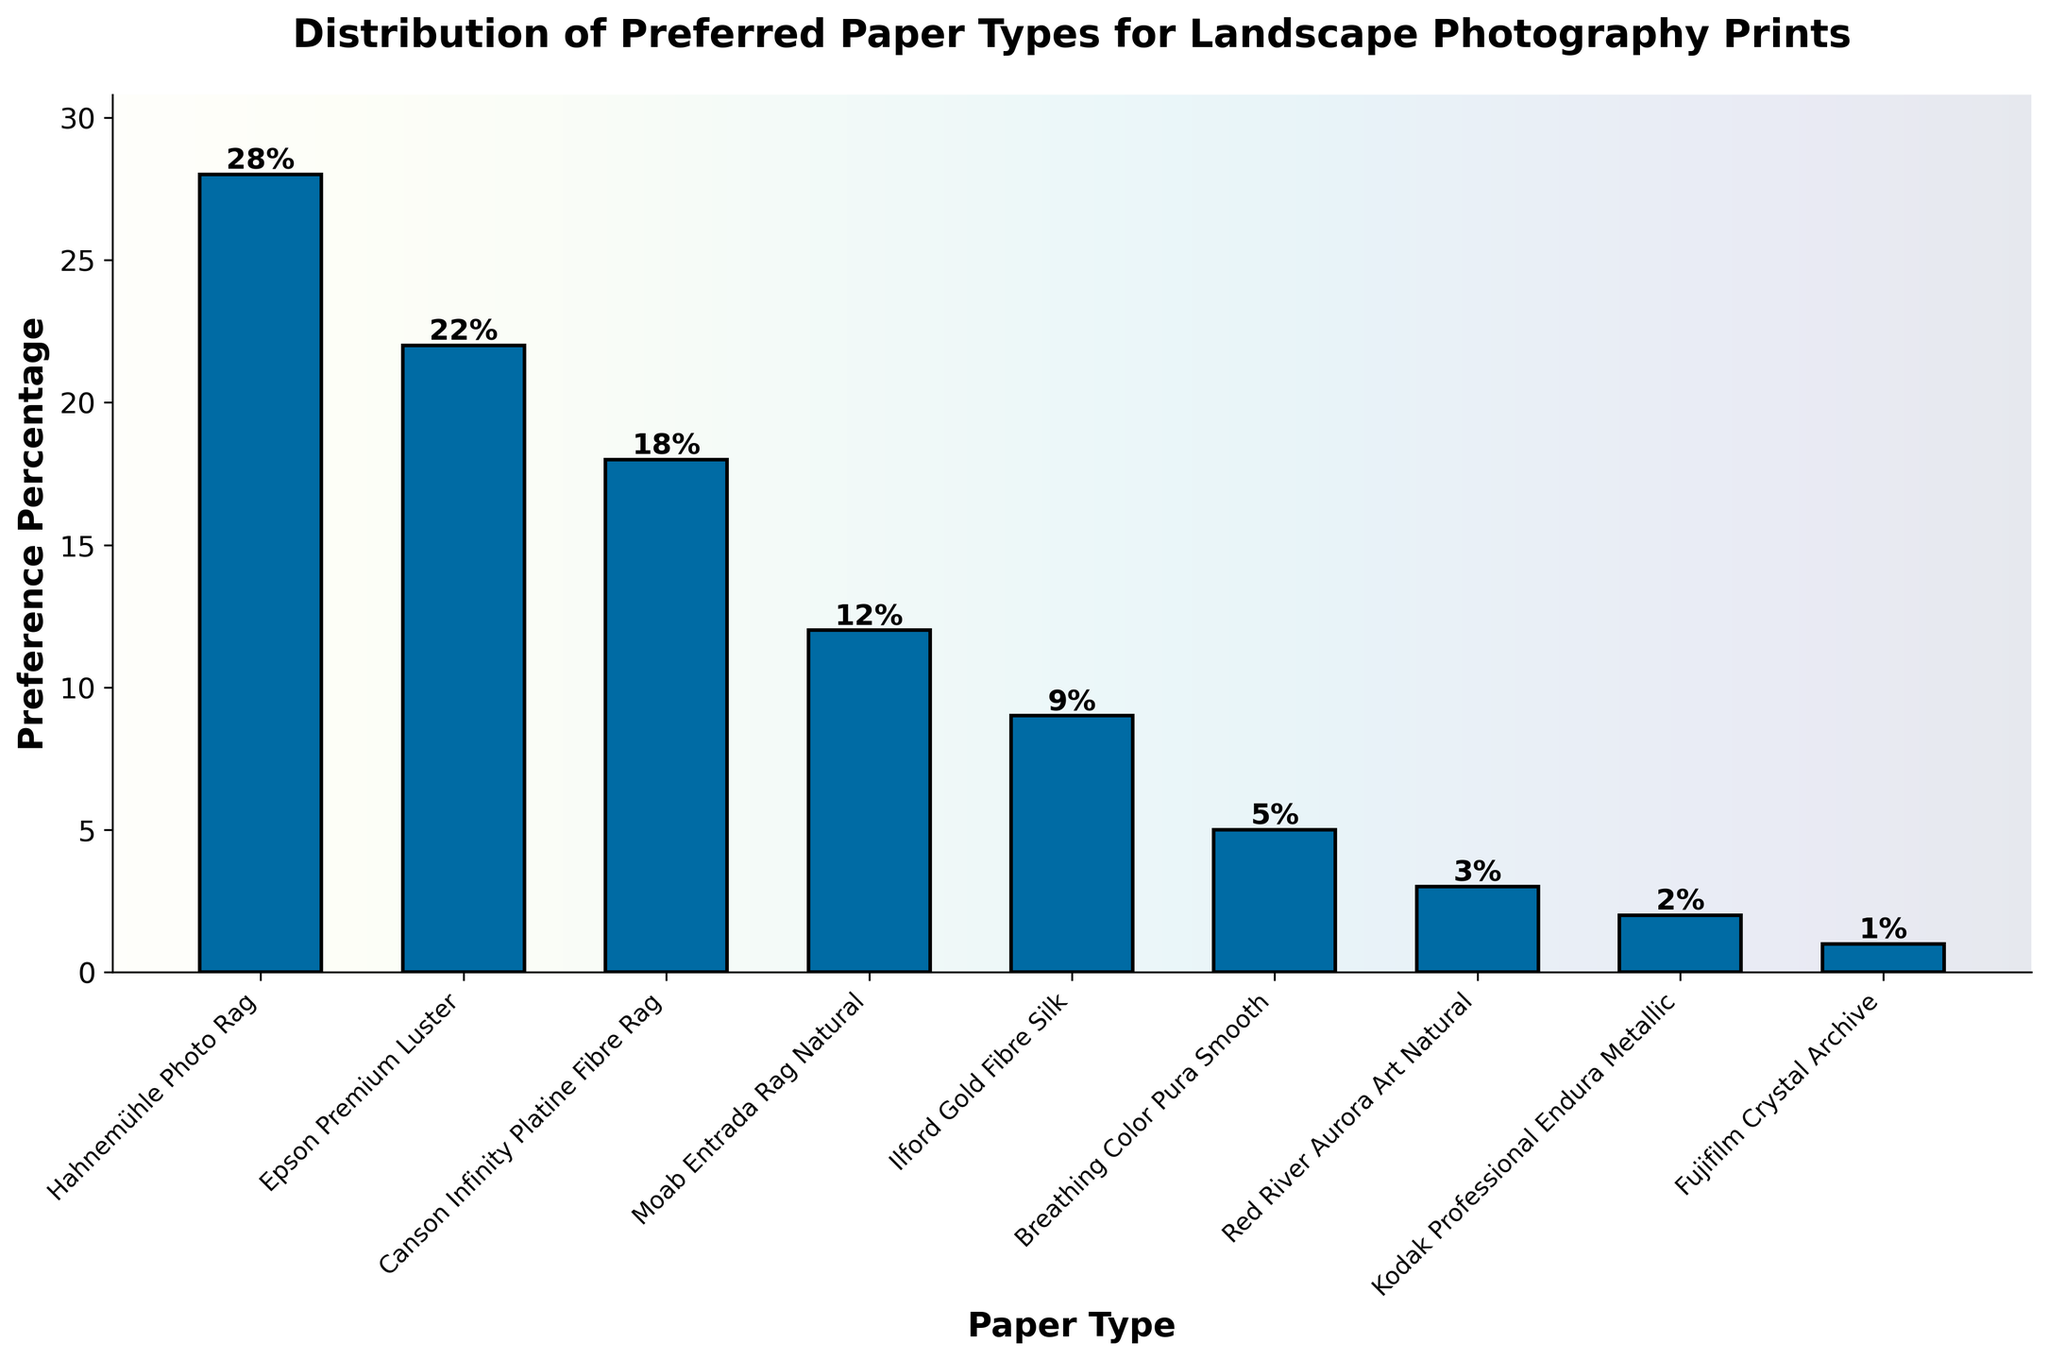What percentage of respondents prefer Hahnemühle Photo Rag? By examining the bar labeled 'Hahnemühle Photo Rag', the height reaches 28, indicating the percentage value next to it.
Answer: 28% Which two paper types have the closest preference percentages and what are those percentages? By visually comparing the bar heights and values, Epson Premium Luster (22%) and Canson Infinity Platine Fibre Rag (18%) are closest, with a difference of 4 percentage points.
Answer: Epson Premium Luster (22%) and Canson Infinity Platine Fibre Rag (18%) How much more popular is Moab Entrada Rag Natural compared to Red River Aurora Art Natural? Subtract the preference percentage of Red River Aurora Art Natural (3%) from Moab Entrada Rag Natural (12%), resulting in a difference of 9%.
Answer: 9% What's the total preference percentage for all the paper types? Adding all the preference percentages: 28 (Hahnemühle Photo Rag) + 22 (Epson Premium Luster) + 18 (Canson Infinity Platine Fibre Rag) + 12 (Moab Entrada Rag Natural) + 9 (Ilford Gold Fibre Silk) + 5 (Breathing Color Pura Smooth) + 3 (Red River Aurora Art Natural) + 2 (Kodak Professional Endura Metallic) + 1 (Fujifilm Crystal Archive) = 100%.
Answer: 100% Which paper type has the lowest preference for landscape photography prints? By identifying the shortest bar, it corresponds to Fujifilm Crystal Archive with a height of 1%.
Answer: Fujifilm Crystal Archive What is the combined preference percentage for Ilford Gold Fibre Silk, Breathing Color Pura Smooth, and Kodak Professional Endura Metallic? Adding the preference percentages of these three types: 9 (Ilford Gold Fibre Silk) + 5 (Breathing Color Pura Smooth) + 2 (Kodak Professional Endura Metallic) = 16%.
Answer: 16% Is Epson Premium Luster preferred more than twice as much compared to Breathing Color Pura Smooth? Epson Premium Luster has a preference of 22% and Breathing Color Pura Smooth has 5%. 5% * 2 = 10%, and 22% is indeed more than 10%.
Answer: Yes What can you infer about the popularity distribution among the paper types from the figure? By observing the bar heights and percentage values, the preference distribution shows steep drops from the most preferred (Hahnemühle Photo Rag) to the least preferred (Fujifilm Crystal Archive), indicating a small number of highly preferred options.
Answer: High concentration of preference in top few types 